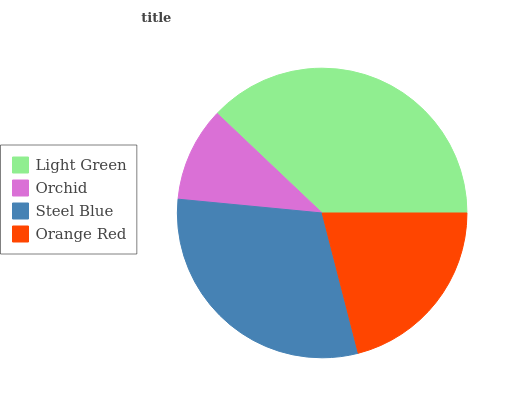Is Orchid the minimum?
Answer yes or no. Yes. Is Light Green the maximum?
Answer yes or no. Yes. Is Steel Blue the minimum?
Answer yes or no. No. Is Steel Blue the maximum?
Answer yes or no. No. Is Steel Blue greater than Orchid?
Answer yes or no. Yes. Is Orchid less than Steel Blue?
Answer yes or no. Yes. Is Orchid greater than Steel Blue?
Answer yes or no. No. Is Steel Blue less than Orchid?
Answer yes or no. No. Is Steel Blue the high median?
Answer yes or no. Yes. Is Orange Red the low median?
Answer yes or no. Yes. Is Light Green the high median?
Answer yes or no. No. Is Orchid the low median?
Answer yes or no. No. 